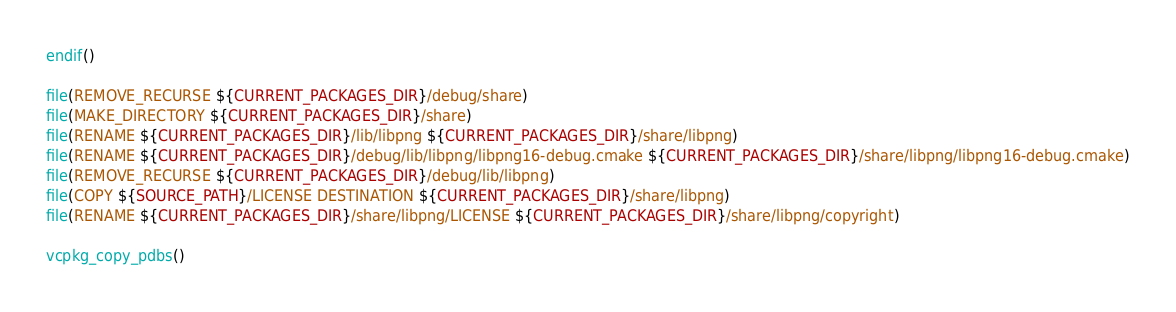Convert code to text. <code><loc_0><loc_0><loc_500><loc_500><_CMake_>endif()

file(REMOVE_RECURSE ${CURRENT_PACKAGES_DIR}/debug/share)
file(MAKE_DIRECTORY ${CURRENT_PACKAGES_DIR}/share)
file(RENAME ${CURRENT_PACKAGES_DIR}/lib/libpng ${CURRENT_PACKAGES_DIR}/share/libpng)
file(RENAME ${CURRENT_PACKAGES_DIR}/debug/lib/libpng/libpng16-debug.cmake ${CURRENT_PACKAGES_DIR}/share/libpng/libpng16-debug.cmake)
file(REMOVE_RECURSE ${CURRENT_PACKAGES_DIR}/debug/lib/libpng)
file(COPY ${SOURCE_PATH}/LICENSE DESTINATION ${CURRENT_PACKAGES_DIR}/share/libpng)
file(RENAME ${CURRENT_PACKAGES_DIR}/share/libpng/LICENSE ${CURRENT_PACKAGES_DIR}/share/libpng/copyright)

vcpkg_copy_pdbs()
</code> 